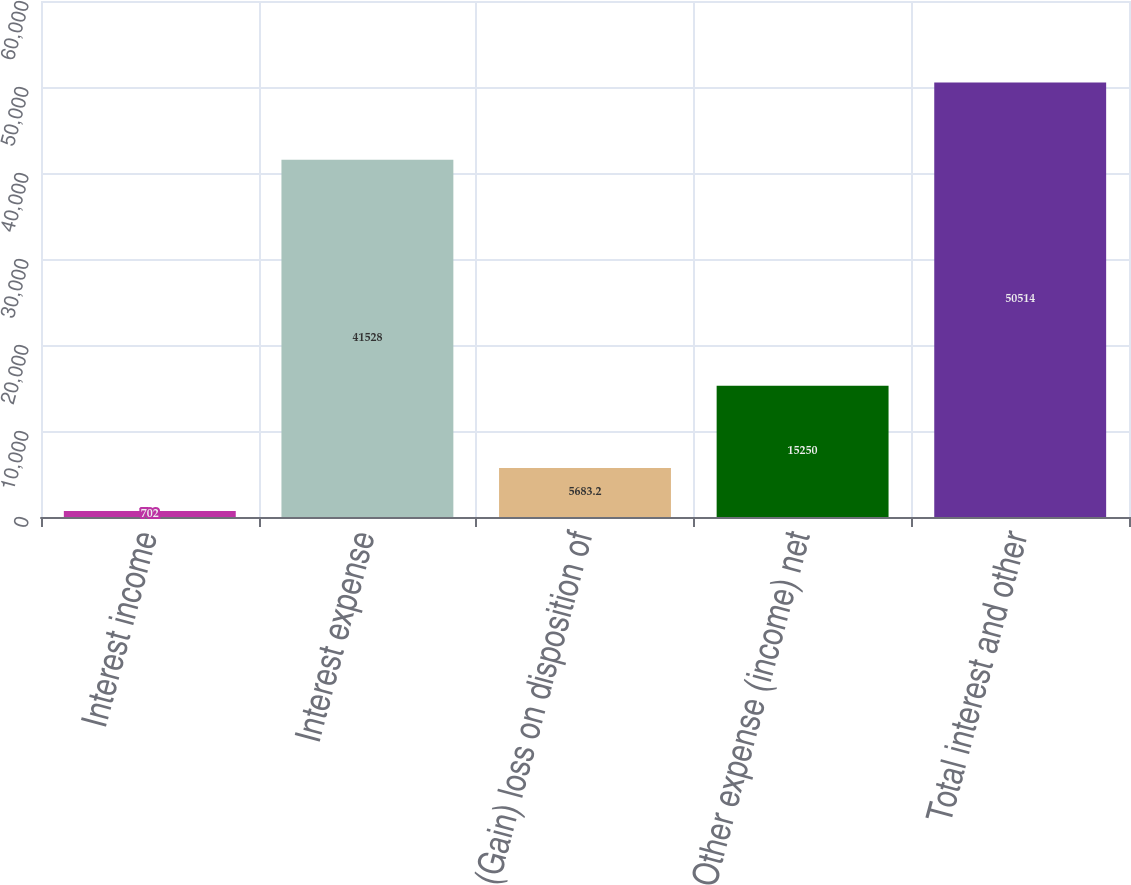Convert chart. <chart><loc_0><loc_0><loc_500><loc_500><bar_chart><fcel>Interest income<fcel>Interest expense<fcel>(Gain) loss on disposition of<fcel>Other expense (income) net<fcel>Total interest and other<nl><fcel>702<fcel>41528<fcel>5683.2<fcel>15250<fcel>50514<nl></chart> 